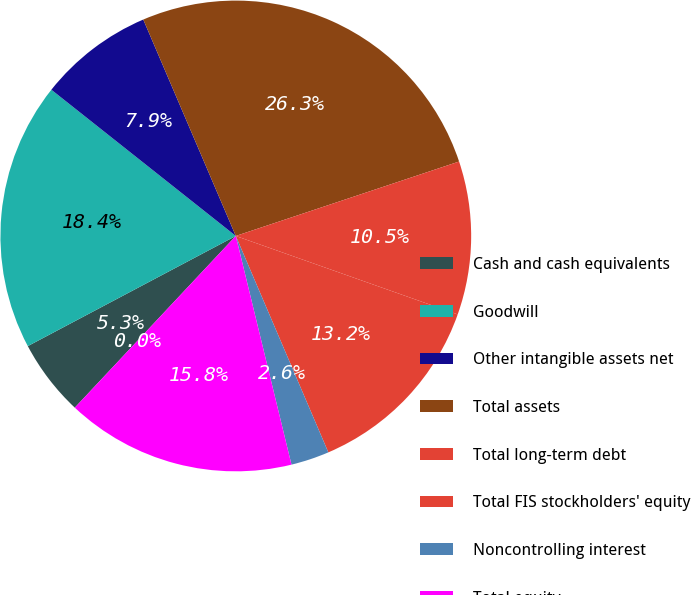<chart> <loc_0><loc_0><loc_500><loc_500><pie_chart><fcel>Cash and cash equivalents<fcel>Goodwill<fcel>Other intangible assets net<fcel>Total assets<fcel>Total long-term debt<fcel>Total FIS stockholders' equity<fcel>Noncontrolling interest<fcel>Total equity<fcel>Cash dividends declared per<nl><fcel>5.26%<fcel>18.42%<fcel>7.9%<fcel>26.31%<fcel>10.53%<fcel>13.16%<fcel>2.63%<fcel>15.79%<fcel>0.0%<nl></chart> 